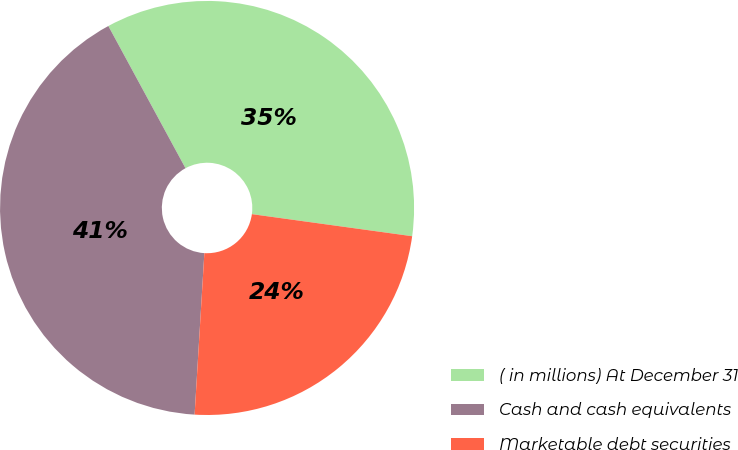Convert chart to OTSL. <chart><loc_0><loc_0><loc_500><loc_500><pie_chart><fcel>( in millions) At December 31<fcel>Cash and cash equivalents<fcel>Marketable debt securities<nl><fcel>35.09%<fcel>41.13%<fcel>23.78%<nl></chart> 